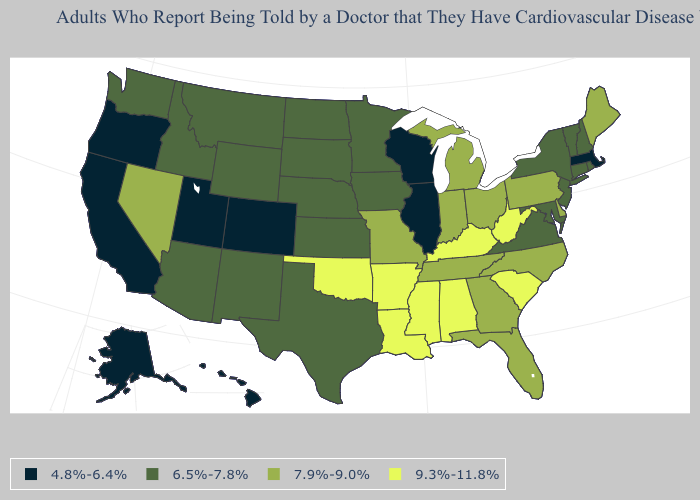What is the value of Delaware?
Give a very brief answer. 7.9%-9.0%. Which states hav the highest value in the Northeast?
Write a very short answer. Maine, Pennsylvania. Does Delaware have the same value as Georgia?
Answer briefly. Yes. Does the first symbol in the legend represent the smallest category?
Concise answer only. Yes. Name the states that have a value in the range 7.9%-9.0%?
Write a very short answer. Delaware, Florida, Georgia, Indiana, Maine, Michigan, Missouri, Nevada, North Carolina, Ohio, Pennsylvania, Tennessee. Name the states that have a value in the range 6.5%-7.8%?
Quick response, please. Arizona, Connecticut, Idaho, Iowa, Kansas, Maryland, Minnesota, Montana, Nebraska, New Hampshire, New Jersey, New Mexico, New York, North Dakota, Rhode Island, South Dakota, Texas, Vermont, Virginia, Washington, Wyoming. Which states have the lowest value in the USA?
Be succinct. Alaska, California, Colorado, Hawaii, Illinois, Massachusetts, Oregon, Utah, Wisconsin. Does Maine have the same value as New Jersey?
Concise answer only. No. Name the states that have a value in the range 9.3%-11.8%?
Write a very short answer. Alabama, Arkansas, Kentucky, Louisiana, Mississippi, Oklahoma, South Carolina, West Virginia. Name the states that have a value in the range 6.5%-7.8%?
Quick response, please. Arizona, Connecticut, Idaho, Iowa, Kansas, Maryland, Minnesota, Montana, Nebraska, New Hampshire, New Jersey, New Mexico, New York, North Dakota, Rhode Island, South Dakota, Texas, Vermont, Virginia, Washington, Wyoming. What is the highest value in the Northeast ?
Be succinct. 7.9%-9.0%. Does Alabama have the highest value in the USA?
Answer briefly. Yes. Name the states that have a value in the range 6.5%-7.8%?
Keep it brief. Arizona, Connecticut, Idaho, Iowa, Kansas, Maryland, Minnesota, Montana, Nebraska, New Hampshire, New Jersey, New Mexico, New York, North Dakota, Rhode Island, South Dakota, Texas, Vermont, Virginia, Washington, Wyoming. What is the lowest value in the USA?
Short answer required. 4.8%-6.4%. Name the states that have a value in the range 6.5%-7.8%?
Answer briefly. Arizona, Connecticut, Idaho, Iowa, Kansas, Maryland, Minnesota, Montana, Nebraska, New Hampshire, New Jersey, New Mexico, New York, North Dakota, Rhode Island, South Dakota, Texas, Vermont, Virginia, Washington, Wyoming. 